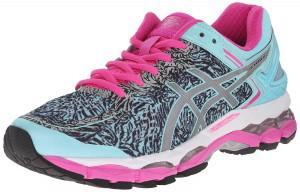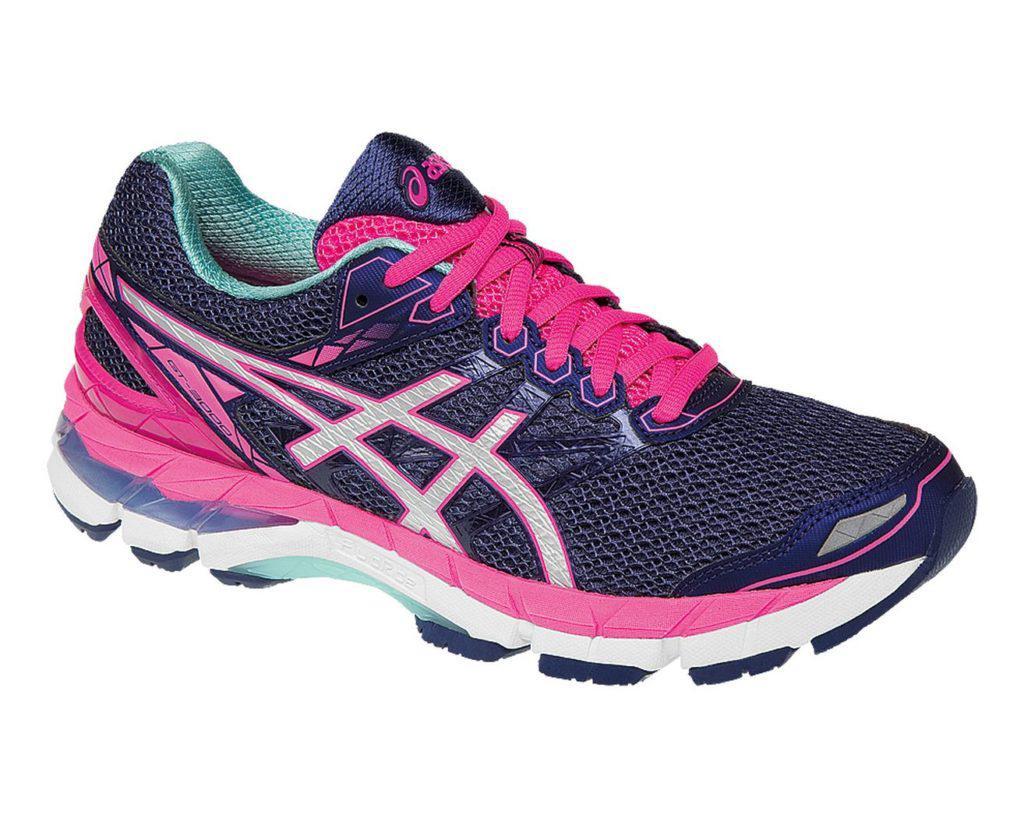The first image is the image on the left, the second image is the image on the right. For the images shown, is this caption "Both shoes have pink shoelaces." true? Answer yes or no. Yes. The first image is the image on the left, the second image is the image on the right. Evaluate the accuracy of this statement regarding the images: "Left and right images each contain a single sneaker, and the pair of images are arranged heel to heel.". Is it true? Answer yes or no. Yes. 